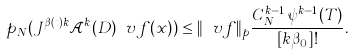<formula> <loc_0><loc_0><loc_500><loc_500>p _ { N } ( J ^ { \beta ( t ) k } \mathcal { A } ^ { k } ( D ) \ v f ( x ) ) \leq \| \ v f \| _ { p } \frac { C _ { N } ^ { k - 1 } \, \psi ^ { k - 1 } ( T ) } { [ k \beta _ { 0 } ] ! } .</formula> 